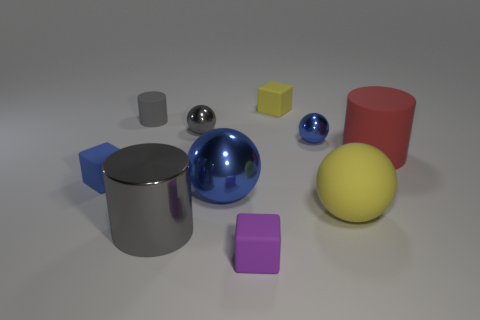How many big blue spheres are behind the tiny matte cube behind the tiny blue block? There are no big blue spheres located behind the tiny matte cube behind the tiny blue block. The image shows that behind the tiny matte cube and the tiny blue block, there are no spheres present. 